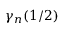Convert formula to latex. <formula><loc_0><loc_0><loc_500><loc_500>\gamma _ { n } ( 1 / 2 )</formula> 